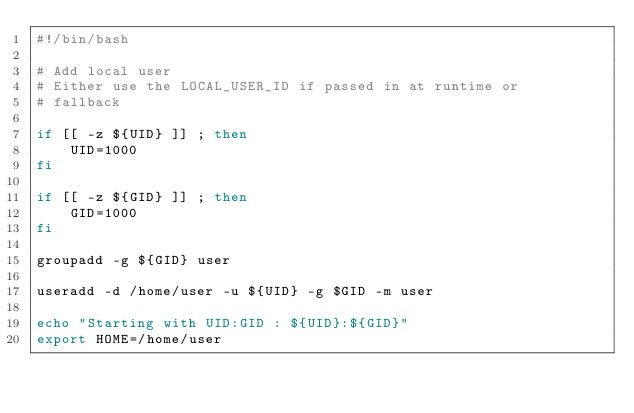Convert code to text. <code><loc_0><loc_0><loc_500><loc_500><_Bash_>#!/bin/bash

# Add local user
# Either use the LOCAL_USER_ID if passed in at runtime or
# fallback

if [[ -z ${UID} ]] ; then
    UID=1000
fi

if [[ -z ${GID} ]] ; then
    GID=1000
fi

groupadd -g ${GID} user

useradd -d /home/user -u ${UID} -g $GID -m user

echo "Starting with UID:GID : ${UID}:${GID}"
export HOME=/home/user
</code> 